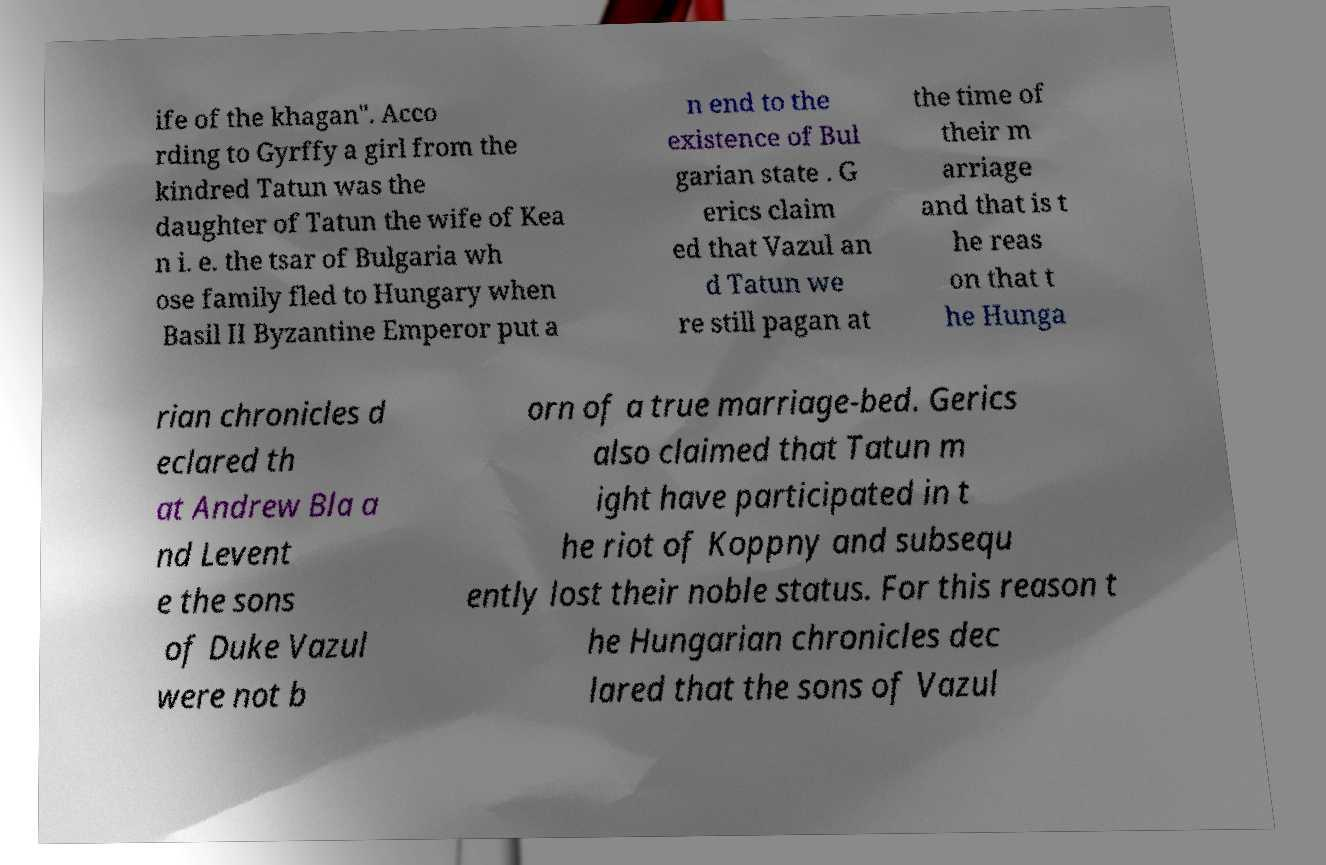I need the written content from this picture converted into text. Can you do that? ife of the khagan". Acco rding to Gyrffy a girl from the kindred Tatun was the daughter of Tatun the wife of Kea n i. e. the tsar of Bulgaria wh ose family fled to Hungary when Basil II Byzantine Emperor put a n end to the existence of Bul garian state . G erics claim ed that Vazul an d Tatun we re still pagan at the time of their m arriage and that is t he reas on that t he Hunga rian chronicles d eclared th at Andrew Bla a nd Levent e the sons of Duke Vazul were not b orn of a true marriage-bed. Gerics also claimed that Tatun m ight have participated in t he riot of Koppny and subsequ ently lost their noble status. For this reason t he Hungarian chronicles dec lared that the sons of Vazul 